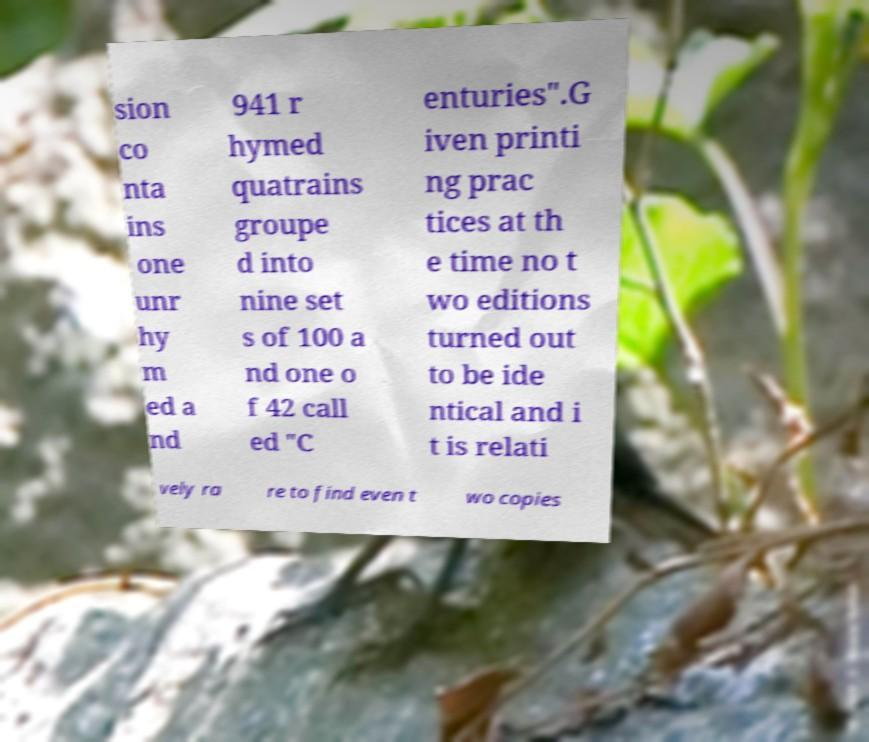For documentation purposes, I need the text within this image transcribed. Could you provide that? sion co nta ins one unr hy m ed a nd 941 r hymed quatrains groupe d into nine set s of 100 a nd one o f 42 call ed "C enturies".G iven printi ng prac tices at th e time no t wo editions turned out to be ide ntical and i t is relati vely ra re to find even t wo copies 